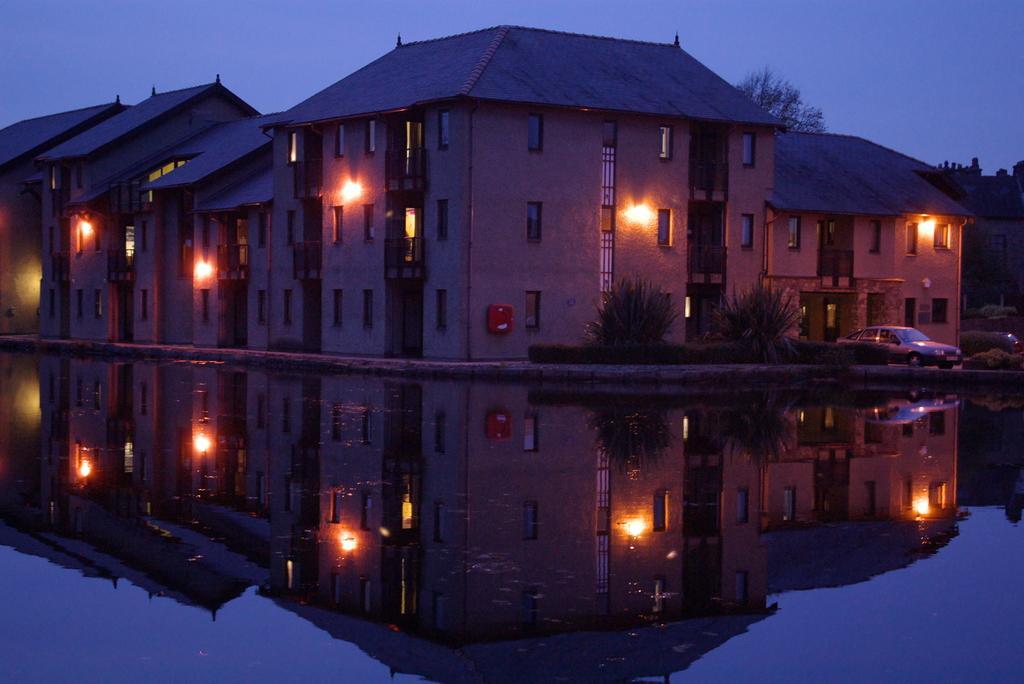In one or two sentences, can you explain what this image depicts? There are houses with the windows, this is water, this is tree and a sky. 